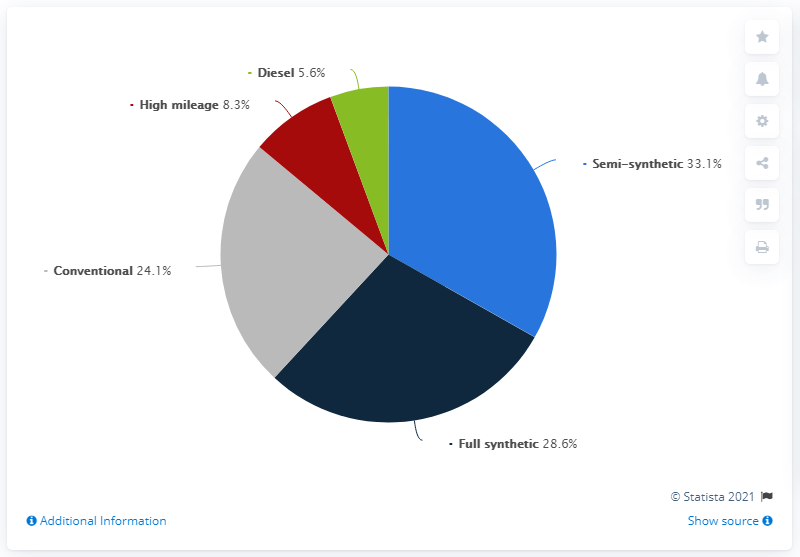Draw attention to some important aspects in this diagram. Conventional ink used in pie segment is typically gray in color. Approximately 5.6% of all oil changes involved the use of diesel oil. The sum total of high mileage and full synthetic motor oil is more than semi-synthetic motor oil. 